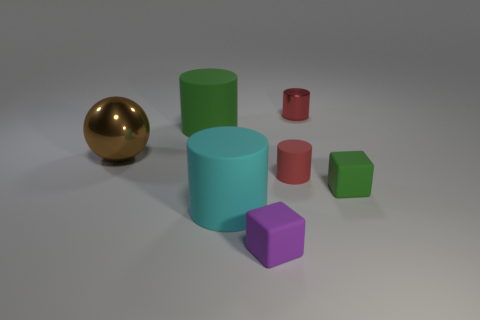How many objects are either purple cubes or matte cylinders?
Provide a short and direct response. 4. There is a matte cylinder that is to the right of the purple object; does it have the same size as the matte object behind the brown object?
Your response must be concise. No. How many blocks are either large things or tiny metal objects?
Provide a succinct answer. 0. Is there a cyan matte object?
Your answer should be very brief. Yes. Is there any other thing that is the same shape as the brown metallic thing?
Ensure brevity in your answer.  No. Is the small metal object the same color as the small matte cylinder?
Provide a short and direct response. Yes. What number of objects are either cylinders that are on the right side of the red matte object or small shiny cylinders?
Ensure brevity in your answer.  1. There is a big matte thing on the right side of the green rubber object behind the small red matte cylinder; what number of small things are left of it?
Provide a short and direct response. 0. What shape is the small red thing in front of the tiny object behind the big matte cylinder behind the cyan matte thing?
Offer a very short reply. Cylinder. What number of other objects are there of the same color as the small metallic cylinder?
Offer a very short reply. 1. 